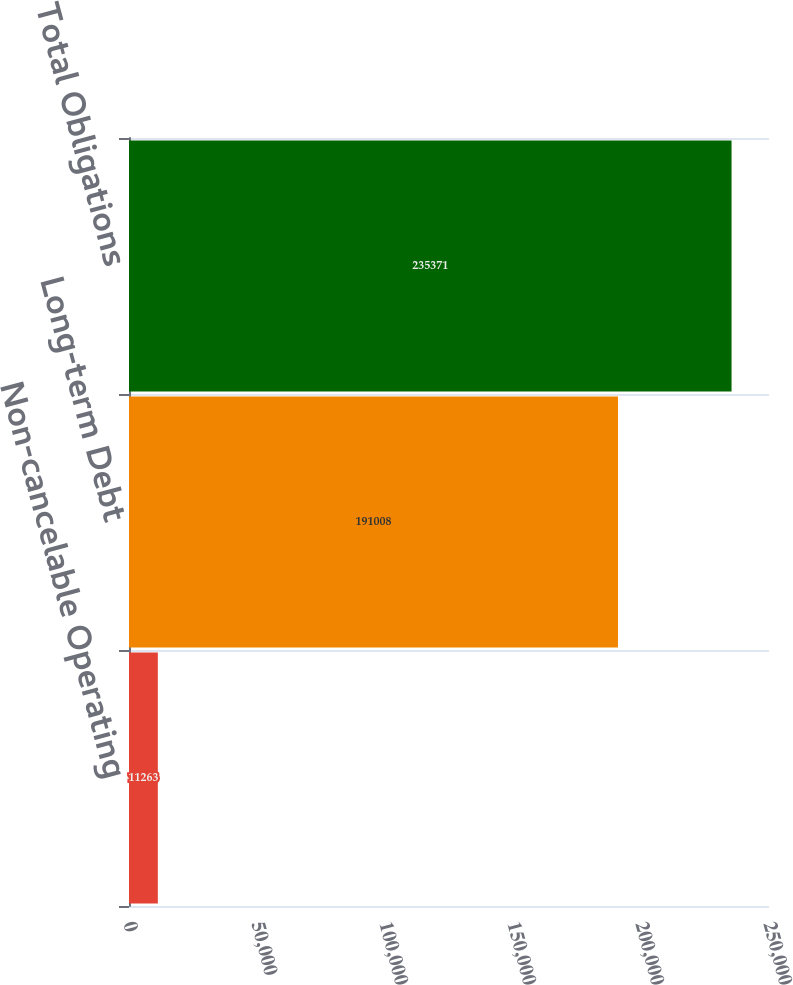Convert chart to OTSL. <chart><loc_0><loc_0><loc_500><loc_500><bar_chart><fcel>Non-cancelable Operating<fcel>Long-term Debt<fcel>Total Obligations<nl><fcel>11263<fcel>191008<fcel>235371<nl></chart> 